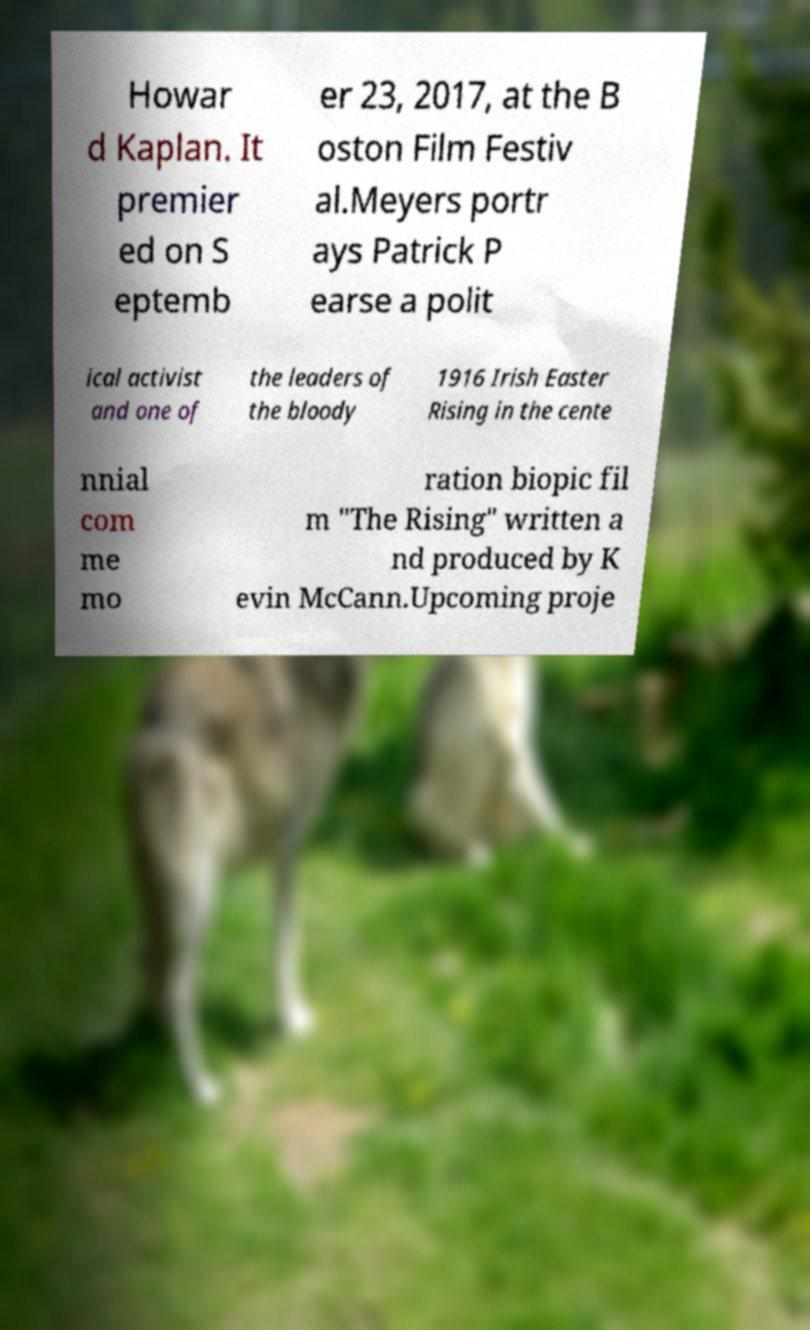Could you extract and type out the text from this image? Howar d Kaplan. It premier ed on S eptemb er 23, 2017, at the B oston Film Festiv al.Meyers portr ays Patrick P earse a polit ical activist and one of the leaders of the bloody 1916 Irish Easter Rising in the cente nnial com me mo ration biopic fil m "The Rising" written a nd produced by K evin McCann.Upcoming proje 